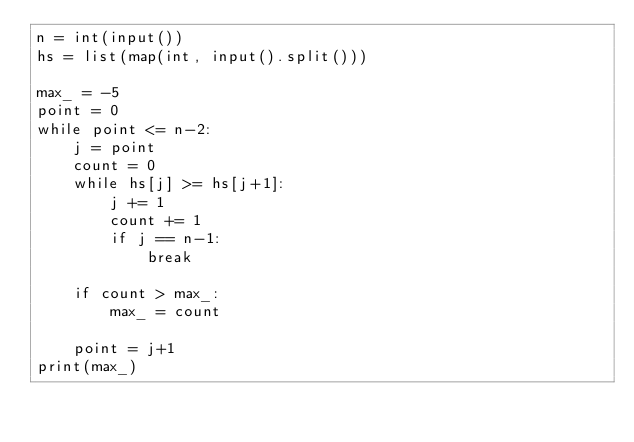<code> <loc_0><loc_0><loc_500><loc_500><_Python_>n = int(input())
hs = list(map(int, input().split()))

max_ = -5
point = 0
while point <= n-2:
    j = point
    count = 0
    while hs[j] >= hs[j+1]:
        j += 1
        count += 1
        if j == n-1:
            break
    
    if count > max_:
        max_ = count
    
    point = j+1
print(max_)</code> 